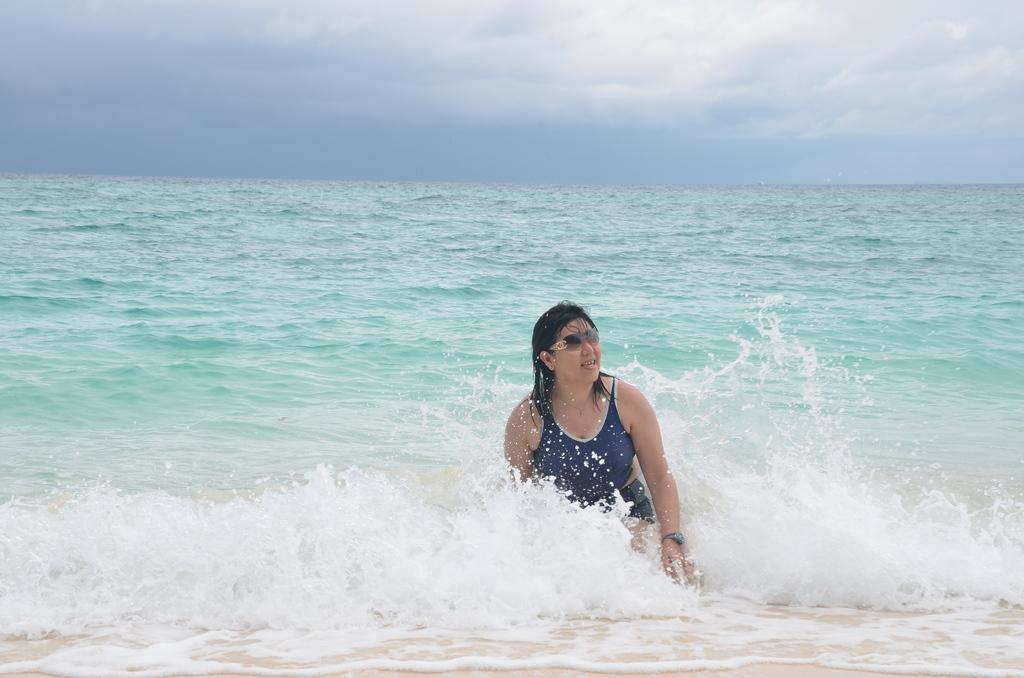How would you summarize this image in a sentence or two? In this image we can see a woman in the water wearing dress and goggles. In the background, we can see the cloudy sky. 